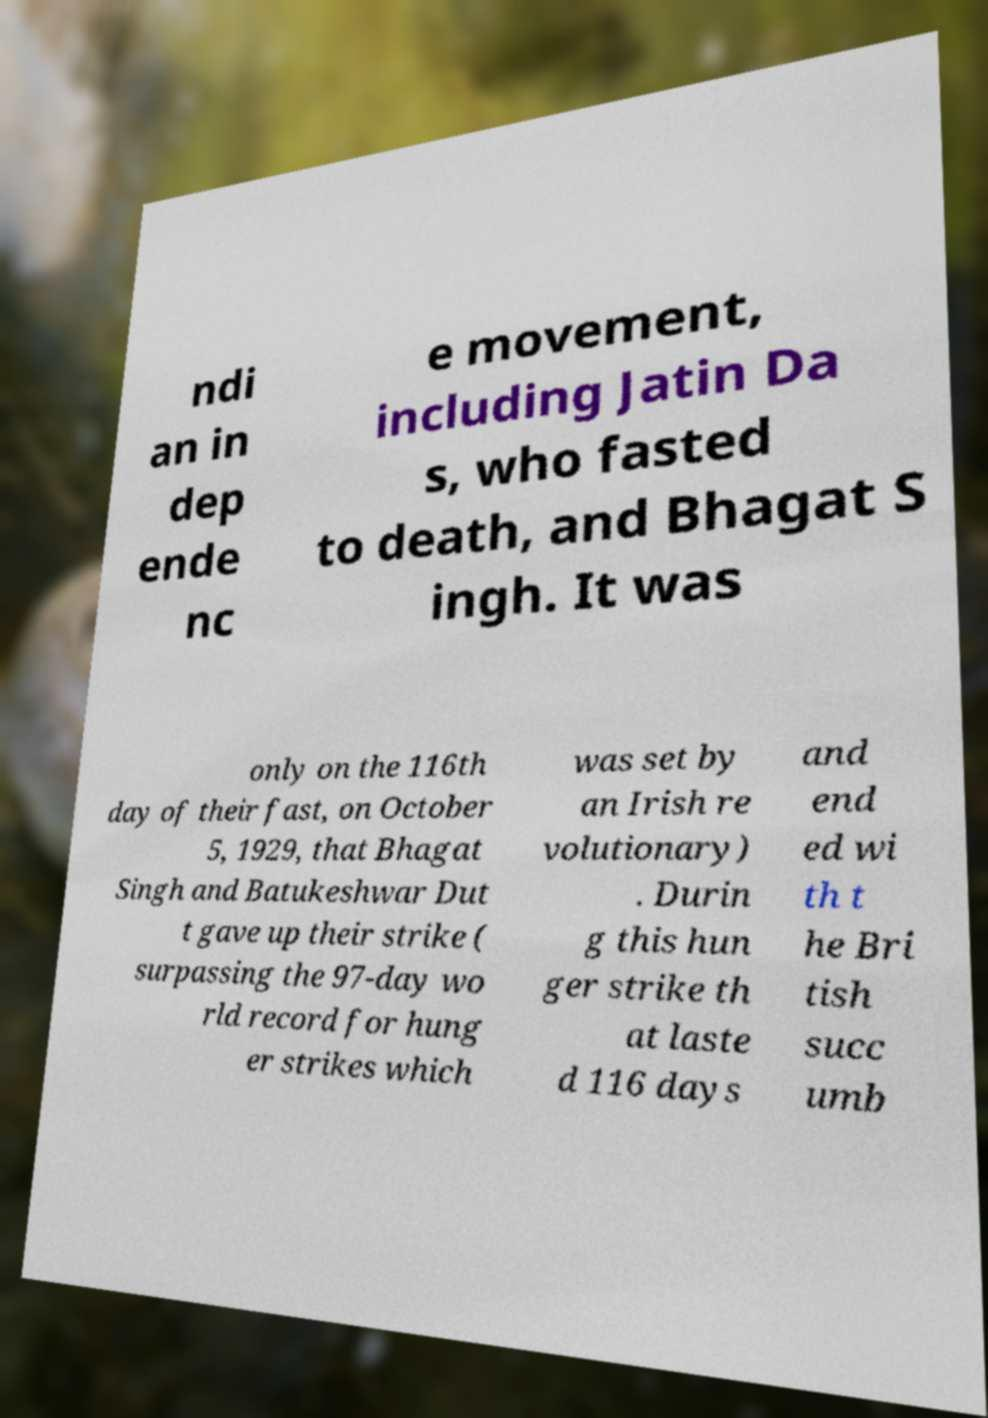Please identify and transcribe the text found in this image. ndi an in dep ende nc e movement, including Jatin Da s, who fasted to death, and Bhagat S ingh. It was only on the 116th day of their fast, on October 5, 1929, that Bhagat Singh and Batukeshwar Dut t gave up their strike ( surpassing the 97-day wo rld record for hung er strikes which was set by an Irish re volutionary) . Durin g this hun ger strike th at laste d 116 days and end ed wi th t he Bri tish succ umb 